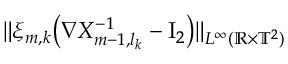Convert formula to latex. <formula><loc_0><loc_0><loc_500><loc_500>\| \xi _ { m , k } \left ( \nabla X _ { m - 1 , l _ { k } } ^ { - 1 } - { I _ { 2 } } \right ) \| _ { L ^ { \infty } ( { \mathbb { R } } \times { \mathbb { T } } ^ { 2 } ) }</formula> 